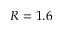<formula> <loc_0><loc_0><loc_500><loc_500>R = 1 . 6</formula> 